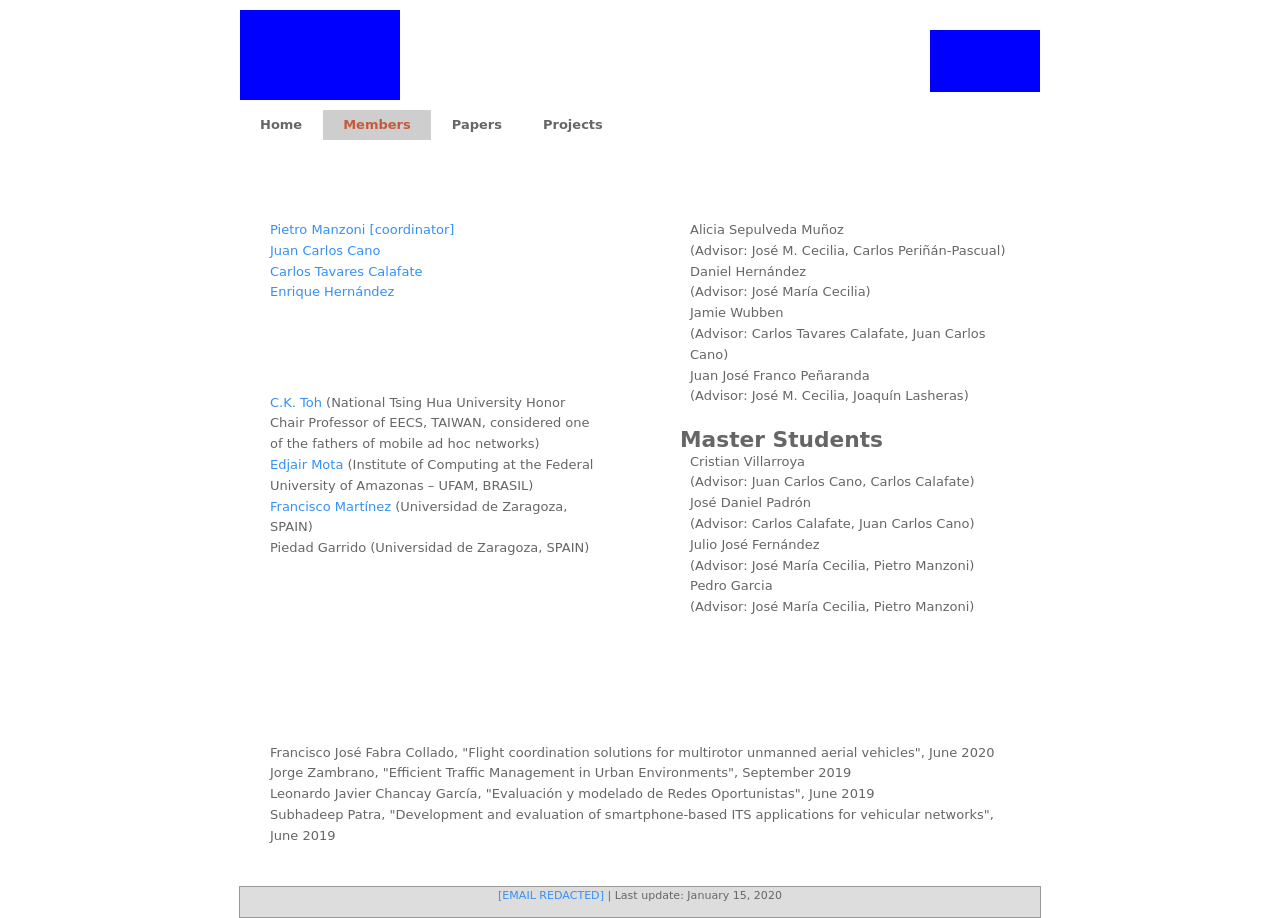How can I start building this website with HTML from the ground up? To create a basic webpage from the ground up with HTML, you can start by establishing the skeletal structure with doctype, HTML, head, and body tags. Within the 'head' section, include style information or link a CSS file for custom styles. In the 'body', you can add elements like headers, paragraphs, images, and links to form the content. Start simple:

<!DOCTYPE html>
<html>
<head>
    <title>Your Website's Title</title>
    <style>
        body { font-family: Arial; }
        h1 { color: navy; }
    </style>
</head>
<body>
    <h1>Welcome to My Website!</h1>
    <p>This is a paragraph of text on my first self-made website.</p>
</body>
</html>

This snippet sets up a minimal webpage with a styled title and a paragraph. Explore adding more elements and styles as you learn more about HTML and CSS. 